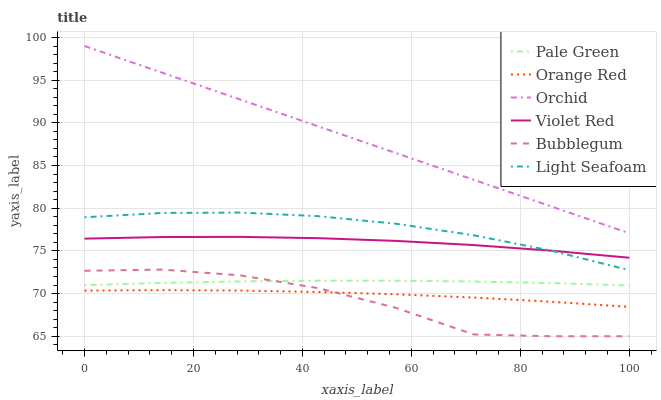Does Bubblegum have the minimum area under the curve?
Answer yes or no. Yes. Does Orchid have the maximum area under the curve?
Answer yes or no. Yes. Does Pale Green have the minimum area under the curve?
Answer yes or no. No. Does Pale Green have the maximum area under the curve?
Answer yes or no. No. Is Orchid the smoothest?
Answer yes or no. Yes. Is Bubblegum the roughest?
Answer yes or no. Yes. Is Pale Green the smoothest?
Answer yes or no. No. Is Pale Green the roughest?
Answer yes or no. No. Does Pale Green have the lowest value?
Answer yes or no. No. Does Bubblegum have the highest value?
Answer yes or no. No. Is Pale Green less than Orchid?
Answer yes or no. Yes. Is Orchid greater than Bubblegum?
Answer yes or no. Yes. Does Pale Green intersect Orchid?
Answer yes or no. No. 